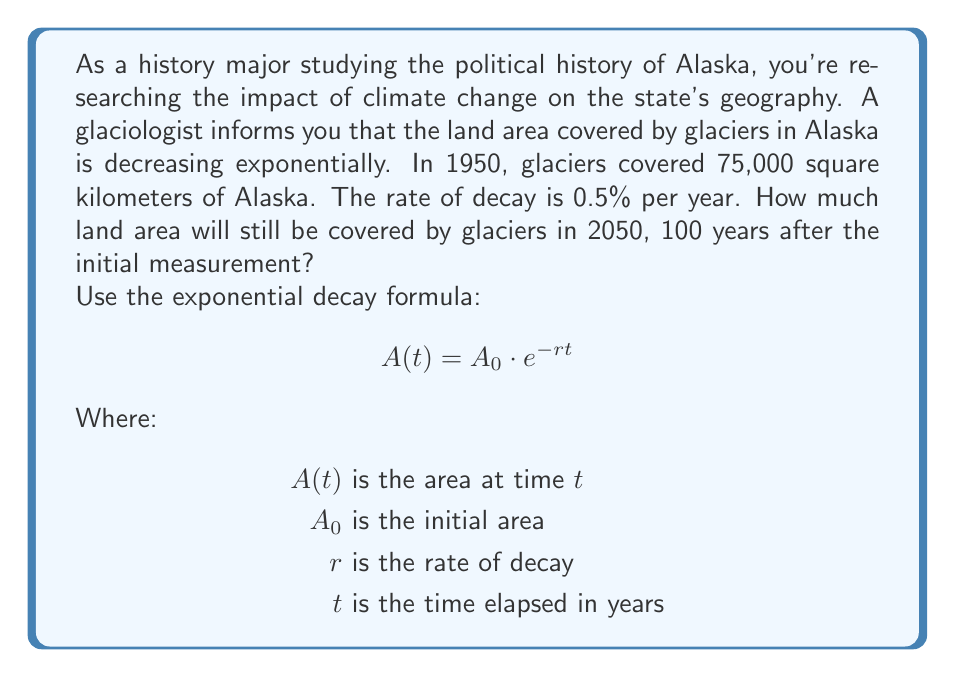Give your solution to this math problem. To solve this problem, we'll use the exponential decay formula:

$$A(t) = A_0 \cdot e^{-rt}$$

Given:
$A_0 = 75,000$ sq km (initial area in 1950)
$r = 0.005$ (0.5% per year expressed as a decimal)
$t = 100$ years (from 1950 to 2050)

Let's substitute these values into the formula:

$$A(100) = 75,000 \cdot e^{-0.005 \cdot 100}$$

Now, let's calculate step by step:

1) First, multiply inside the exponent:
   $$A(100) = 75,000 \cdot e^{-0.5}$$

2) Calculate $e^{-0.5}$ using a calculator:
   $e^{-0.5} \approx 0.6065$

3) Multiply this by the initial area:
   $$A(100) = 75,000 \cdot 0.6065 \approx 45,487.5$$

Therefore, after 100 years, in 2050, approximately 45,487.5 square kilometers of Alaska will still be covered by glaciers.
Answer: In 2050, approximately 45,487.5 square kilometers of Alaska will still be covered by glaciers. 